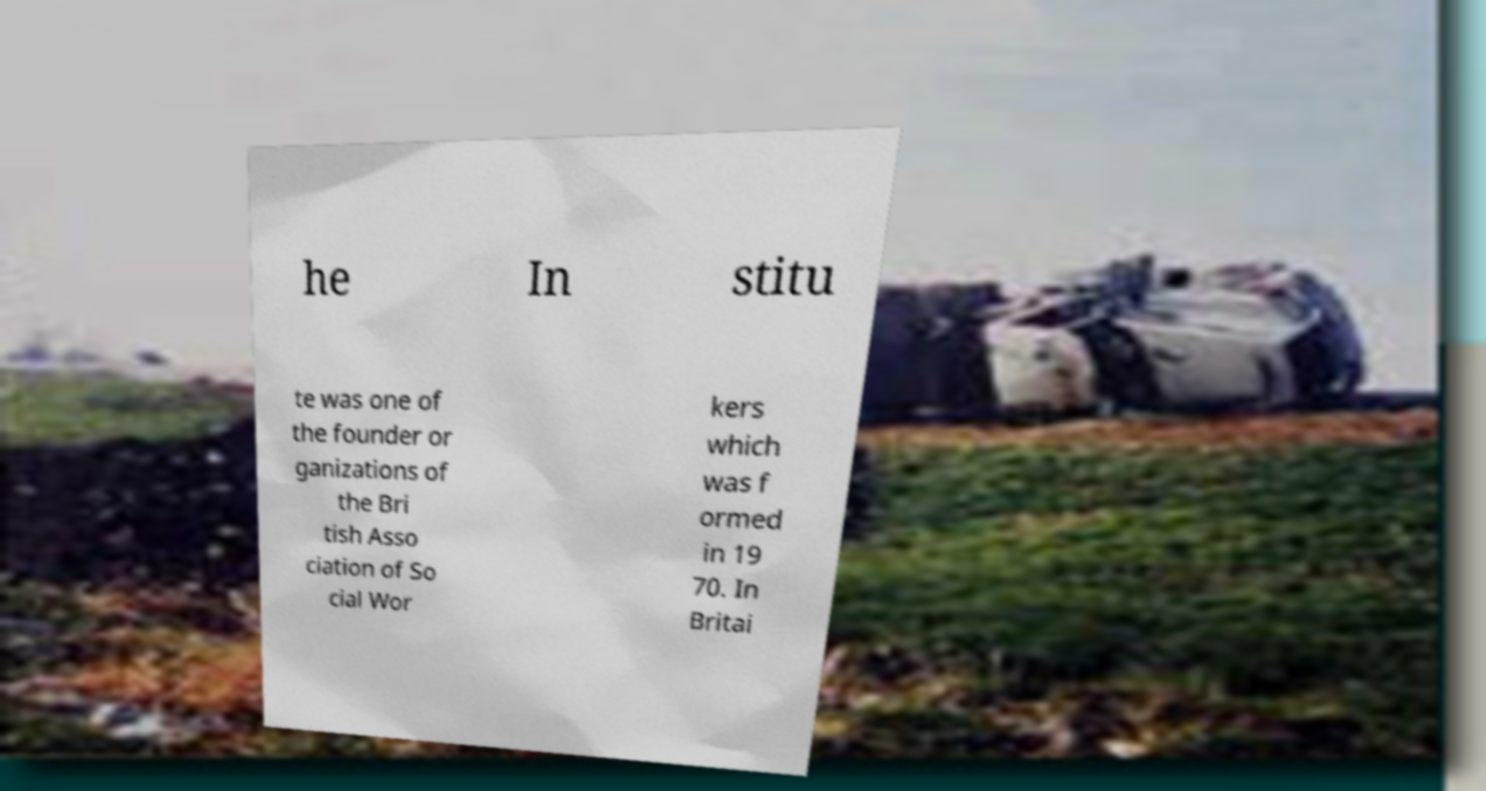For documentation purposes, I need the text within this image transcribed. Could you provide that? he In stitu te was one of the founder or ganizations of the Bri tish Asso ciation of So cial Wor kers which was f ormed in 19 70. In Britai 